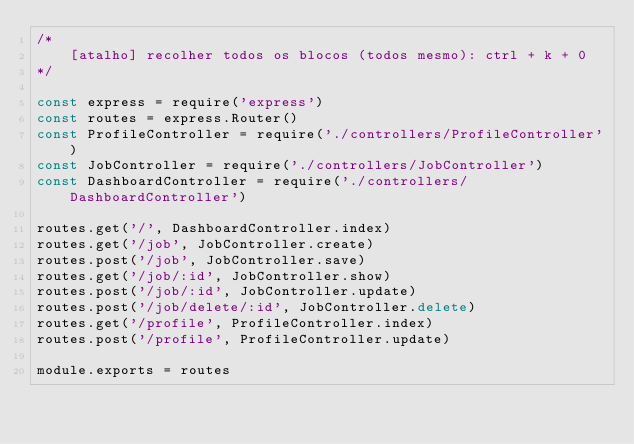<code> <loc_0><loc_0><loc_500><loc_500><_JavaScript_>/*
    [atalho] recolher todos os blocos (todos mesmo): ctrl + k + 0
*/

const express = require('express')
const routes = express.Router()
const ProfileController = require('./controllers/ProfileController')
const JobController = require('./controllers/JobController')
const DashboardController = require('./controllers/DashboardController')

routes.get('/', DashboardController.index)
routes.get('/job', JobController.create)
routes.post('/job', JobController.save)
routes.get('/job/:id', JobController.show)
routes.post('/job/:id', JobController.update)
routes.post('/job/delete/:id', JobController.delete)
routes.get('/profile', ProfileController.index)
routes.post('/profile', ProfileController.update)

module.exports = routes</code> 